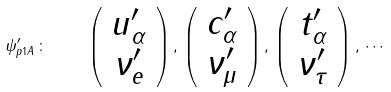Convert formula to latex. <formula><loc_0><loc_0><loc_500><loc_500>\psi ^ { \prime } _ { p 1 A } \, \colon \quad \left ( \begin{array} { c } u ^ { \prime } _ { \alpha } \\ \nu ^ { \prime } _ { e } \end{array} \right ) , \, \left ( \begin{array} { c } c ^ { \prime } _ { \alpha } \\ \nu ^ { \prime } _ { \mu } \end{array} \right ) , \, \left ( \begin{array} { c } t ^ { \prime } _ { \alpha } \\ \nu ^ { \prime } _ { \tau } \end{array} \right ) , \, \cdots</formula> 